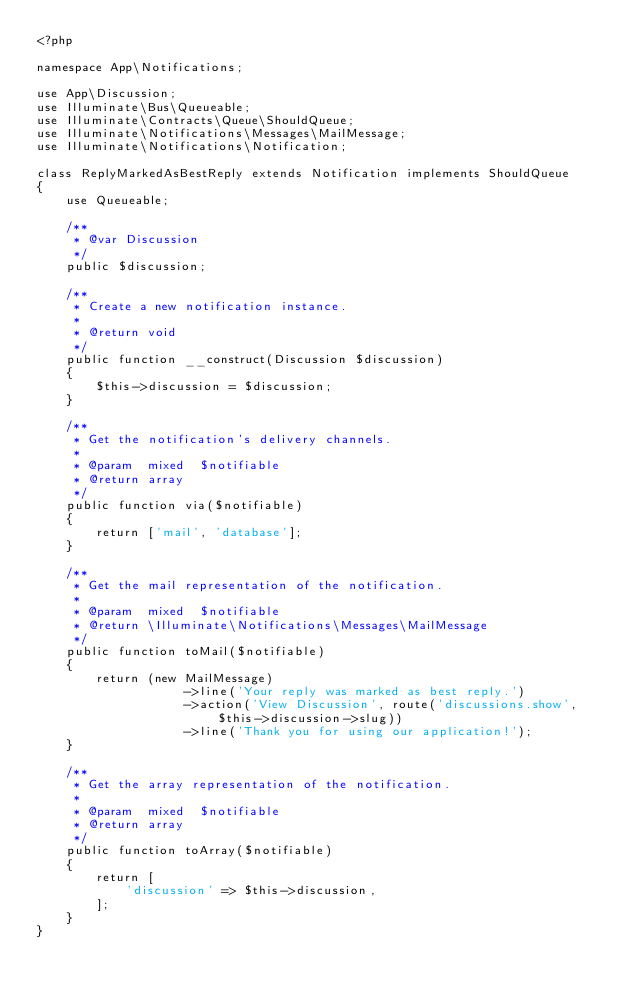Convert code to text. <code><loc_0><loc_0><loc_500><loc_500><_PHP_><?php

namespace App\Notifications;

use App\Discussion;
use Illuminate\Bus\Queueable;
use Illuminate\Contracts\Queue\ShouldQueue;
use Illuminate\Notifications\Messages\MailMessage;
use Illuminate\Notifications\Notification;

class ReplyMarkedAsBestReply extends Notification implements ShouldQueue
{
    use Queueable;

    /**
     * @var Discussion
     */
    public $discussion;

    /**
     * Create a new notification instance.
     *
     * @return void
     */
    public function __construct(Discussion $discussion)
    {
        $this->discussion = $discussion;
    }

    /**
     * Get the notification's delivery channels.
     *
     * @param  mixed  $notifiable
     * @return array
     */
    public function via($notifiable)
    {
        return ['mail', 'database'];
    }

    /**
     * Get the mail representation of the notification.
     *
     * @param  mixed  $notifiable
     * @return \Illuminate\Notifications\Messages\MailMessage
     */
    public function toMail($notifiable)
    {
        return (new MailMessage)
                    ->line('Your reply was marked as best reply.')
                    ->action('View Discussion', route('discussions.show', $this->discussion->slug))
                    ->line('Thank you for using our application!');
    }

    /**
     * Get the array representation of the notification.
     *
     * @param  mixed  $notifiable
     * @return array
     */
    public function toArray($notifiable)
    {
        return [
            'discussion' => $this->discussion,
        ];
    }
}
</code> 